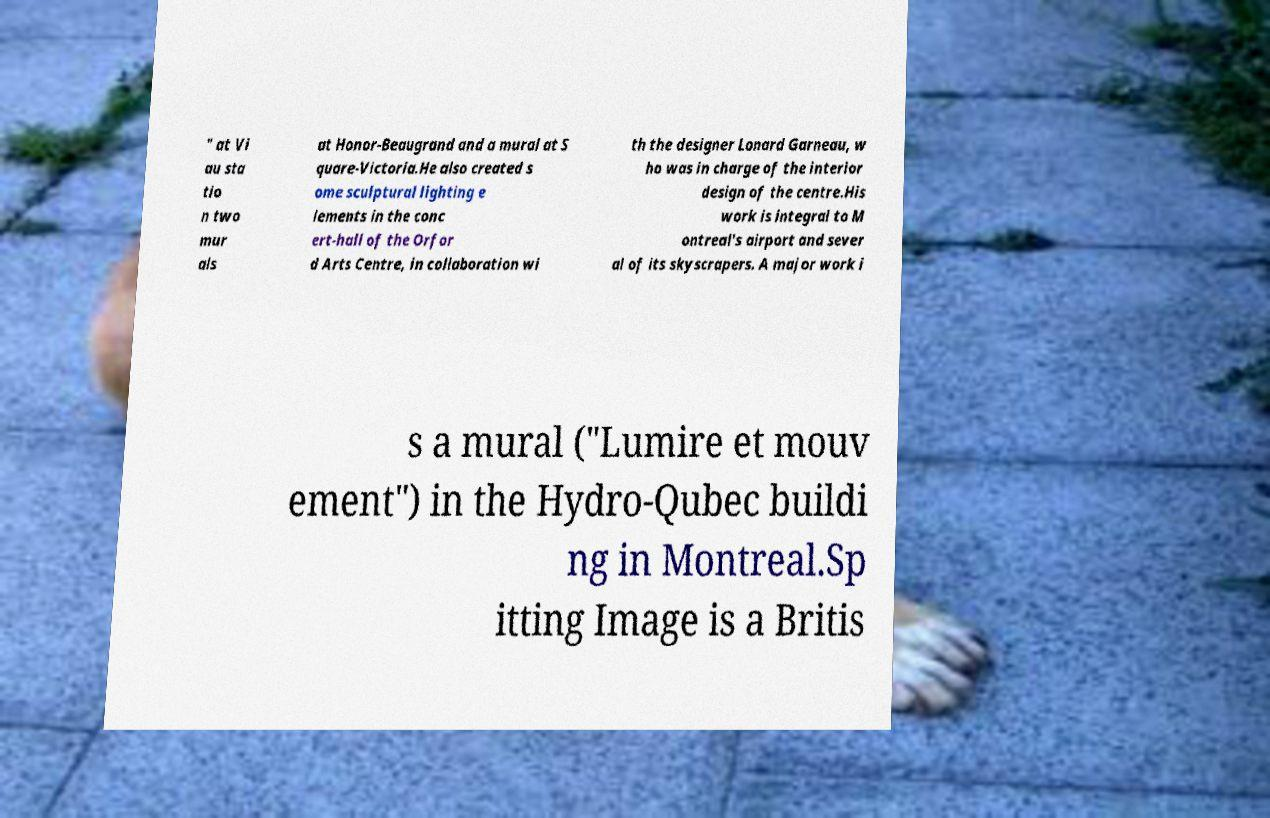I need the written content from this picture converted into text. Can you do that? " at Vi au sta tio n two mur als at Honor-Beaugrand and a mural at S quare-Victoria.He also created s ome sculptural lighting e lements in the conc ert-hall of the Orfor d Arts Centre, in collaboration wi th the designer Lonard Garneau, w ho was in charge of the interior design of the centre.His work is integral to M ontreal's airport and sever al of its skyscrapers. A major work i s a mural ("Lumire et mouv ement") in the Hydro-Qubec buildi ng in Montreal.Sp itting Image is a Britis 